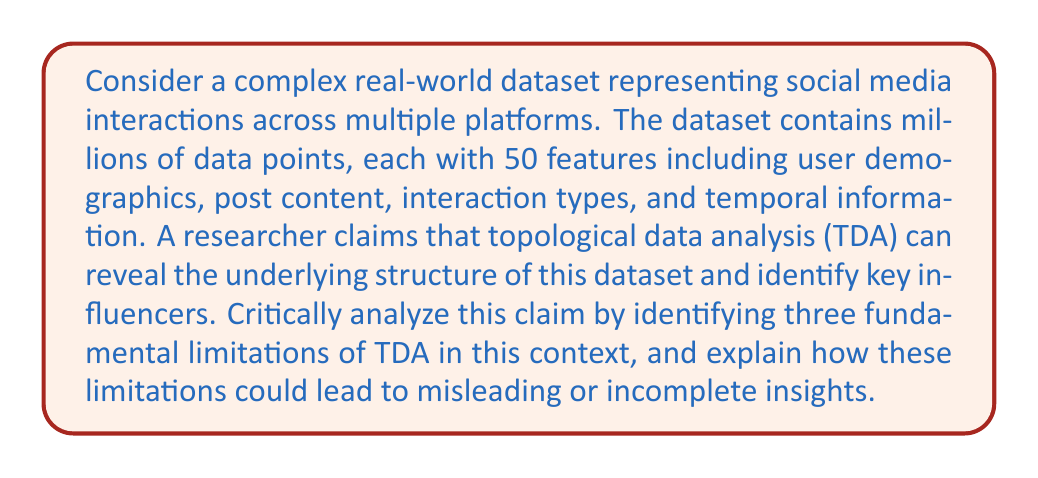Help me with this question. To analyze the limitations of topological data analysis (TDA) in this complex real-world dataset, we need to consider the following aspects:

1. Curse of dimensionality:
TDA relies on the construction of simplicial complexes or persistent homology, which become computationally intractable as the dimensionality of the data increases. In this case, we have 50 features per data point.

The computational complexity for constructing a Vietoris-Rips complex, a common approach in TDA, is approximately $O(n^d)$, where $n$ is the number of data points and $d$ is the dimension. With millions of data points and 50 dimensions, this becomes computationally infeasible.

Limitation: TDA may require dimension reduction techniques, potentially losing important information and introducing bias in the analysis.

2. Sensitivity to noise and outliers:
Real-world social media data is inherently noisy and contains outliers. TDA methods, particularly those based on persistent homology, can be sensitive to noise and outliers.

The stability theorem for persistent homology states that the bottleneck distance between persistence diagrams is bounded by the Hausdorff distance between the underlying spaces:

$$ d_B(Dgm(f), Dgm(g)) \leq ||f - g||_\infty $$

Where $d_B$ is the bottleneck distance, $Dgm(f)$ and $Dgm(g)$ are persistence diagrams, and $||f - g||_\infty$ is the supremum norm.

Limitation: Noisy data points or outliers can significantly alter the topological features detected, leading to misinterpretation of the underlying structure.

3. Lack of interpretability in high-dimensional spaces:
TDA provides information about the shape and structure of data, but interpreting these results becomes challenging in high-dimensional spaces.

For example, the Mapper algorithm, a popular TDA technique, produces a graph representation of the data. In high dimensions, the meaning of "nearness" or "connectivity" becomes less intuitive, making it difficult to interpret the resulting graph in terms of the original features.

Limitation: The abstract nature of topological features in high-dimensional spaces can make it difficult to translate findings into actionable insights about social media interactions and influencers.

These limitations demonstrate that while TDA can provide valuable insights, it is not a panacea for understanding complex real-world datasets. The researcher's claim should be approached with skepticism, as TDA alone is unlikely to reveal the full underlying structure and accurately identify key influencers in this context.
Answer: The three fundamental limitations of TDA in analyzing the given complex real-world social media dataset are:

1. Curse of dimensionality: Computational intractability with high-dimensional data, requiring dimension reduction that may introduce bias.

2. Sensitivity to noise and outliers: Topological features can be significantly altered by noisy data points or outliers, leading to misinterpretation.

3. Lack of interpretability in high-dimensional spaces: Difficulty in translating abstract topological features into meaningful insights about social media interactions and influencers. 